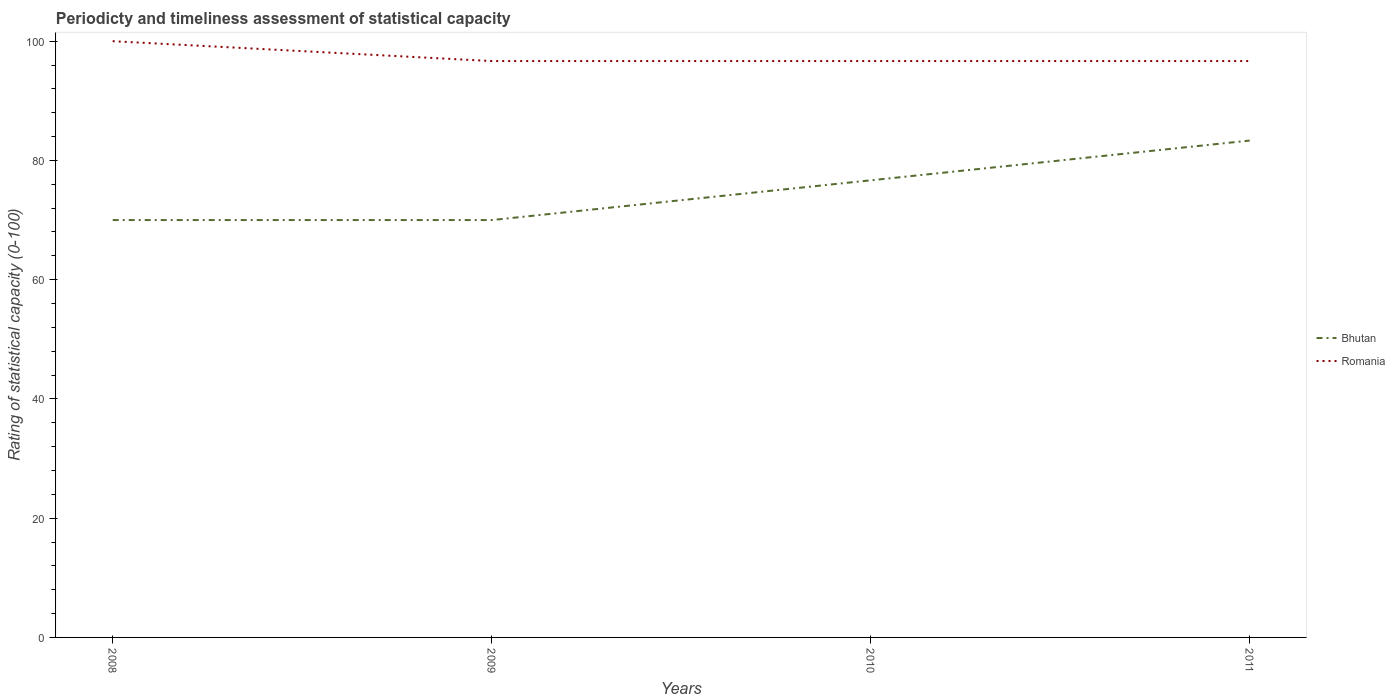Does the line corresponding to Romania intersect with the line corresponding to Bhutan?
Keep it short and to the point. No. Is the number of lines equal to the number of legend labels?
Provide a succinct answer. Yes. Across all years, what is the maximum rating of statistical capacity in Romania?
Your response must be concise. 96.67. What is the total rating of statistical capacity in Romania in the graph?
Give a very brief answer. 3.33. What is the difference between the highest and the second highest rating of statistical capacity in Bhutan?
Ensure brevity in your answer.  13.33. Is the rating of statistical capacity in Bhutan strictly greater than the rating of statistical capacity in Romania over the years?
Your response must be concise. Yes. What is the difference between two consecutive major ticks on the Y-axis?
Offer a very short reply. 20. Does the graph contain any zero values?
Your answer should be compact. No. What is the title of the graph?
Ensure brevity in your answer.  Periodicty and timeliness assessment of statistical capacity. Does "New Zealand" appear as one of the legend labels in the graph?
Ensure brevity in your answer.  No. What is the label or title of the X-axis?
Give a very brief answer. Years. What is the label or title of the Y-axis?
Make the answer very short. Rating of statistical capacity (0-100). What is the Rating of statistical capacity (0-100) of Bhutan in 2008?
Give a very brief answer. 70. What is the Rating of statistical capacity (0-100) in Romania in 2008?
Your answer should be compact. 100. What is the Rating of statistical capacity (0-100) in Romania in 2009?
Your response must be concise. 96.67. What is the Rating of statistical capacity (0-100) in Bhutan in 2010?
Your response must be concise. 76.67. What is the Rating of statistical capacity (0-100) in Romania in 2010?
Ensure brevity in your answer.  96.67. What is the Rating of statistical capacity (0-100) in Bhutan in 2011?
Ensure brevity in your answer.  83.33. What is the Rating of statistical capacity (0-100) in Romania in 2011?
Offer a very short reply. 96.67. Across all years, what is the maximum Rating of statistical capacity (0-100) of Bhutan?
Offer a terse response. 83.33. Across all years, what is the minimum Rating of statistical capacity (0-100) in Bhutan?
Provide a succinct answer. 70. Across all years, what is the minimum Rating of statistical capacity (0-100) of Romania?
Make the answer very short. 96.67. What is the total Rating of statistical capacity (0-100) of Bhutan in the graph?
Provide a short and direct response. 300. What is the total Rating of statistical capacity (0-100) in Romania in the graph?
Offer a terse response. 390. What is the difference between the Rating of statistical capacity (0-100) in Bhutan in 2008 and that in 2009?
Offer a terse response. 0. What is the difference between the Rating of statistical capacity (0-100) in Romania in 2008 and that in 2009?
Offer a terse response. 3.33. What is the difference between the Rating of statistical capacity (0-100) in Bhutan in 2008 and that in 2010?
Make the answer very short. -6.67. What is the difference between the Rating of statistical capacity (0-100) in Romania in 2008 and that in 2010?
Offer a terse response. 3.33. What is the difference between the Rating of statistical capacity (0-100) in Bhutan in 2008 and that in 2011?
Provide a succinct answer. -13.33. What is the difference between the Rating of statistical capacity (0-100) of Romania in 2008 and that in 2011?
Your answer should be very brief. 3.33. What is the difference between the Rating of statistical capacity (0-100) of Bhutan in 2009 and that in 2010?
Ensure brevity in your answer.  -6.67. What is the difference between the Rating of statistical capacity (0-100) of Romania in 2009 and that in 2010?
Your response must be concise. 0. What is the difference between the Rating of statistical capacity (0-100) in Bhutan in 2009 and that in 2011?
Your answer should be compact. -13.33. What is the difference between the Rating of statistical capacity (0-100) in Romania in 2009 and that in 2011?
Give a very brief answer. 0. What is the difference between the Rating of statistical capacity (0-100) of Bhutan in 2010 and that in 2011?
Provide a succinct answer. -6.67. What is the difference between the Rating of statistical capacity (0-100) in Bhutan in 2008 and the Rating of statistical capacity (0-100) in Romania in 2009?
Keep it short and to the point. -26.67. What is the difference between the Rating of statistical capacity (0-100) of Bhutan in 2008 and the Rating of statistical capacity (0-100) of Romania in 2010?
Your response must be concise. -26.67. What is the difference between the Rating of statistical capacity (0-100) in Bhutan in 2008 and the Rating of statistical capacity (0-100) in Romania in 2011?
Offer a terse response. -26.67. What is the difference between the Rating of statistical capacity (0-100) of Bhutan in 2009 and the Rating of statistical capacity (0-100) of Romania in 2010?
Your response must be concise. -26.67. What is the difference between the Rating of statistical capacity (0-100) of Bhutan in 2009 and the Rating of statistical capacity (0-100) of Romania in 2011?
Your response must be concise. -26.67. What is the difference between the Rating of statistical capacity (0-100) of Bhutan in 2010 and the Rating of statistical capacity (0-100) of Romania in 2011?
Make the answer very short. -20. What is the average Rating of statistical capacity (0-100) in Bhutan per year?
Provide a succinct answer. 75. What is the average Rating of statistical capacity (0-100) of Romania per year?
Provide a short and direct response. 97.5. In the year 2009, what is the difference between the Rating of statistical capacity (0-100) in Bhutan and Rating of statistical capacity (0-100) in Romania?
Ensure brevity in your answer.  -26.67. In the year 2010, what is the difference between the Rating of statistical capacity (0-100) in Bhutan and Rating of statistical capacity (0-100) in Romania?
Give a very brief answer. -20. In the year 2011, what is the difference between the Rating of statistical capacity (0-100) in Bhutan and Rating of statistical capacity (0-100) in Romania?
Make the answer very short. -13.33. What is the ratio of the Rating of statistical capacity (0-100) in Romania in 2008 to that in 2009?
Offer a very short reply. 1.03. What is the ratio of the Rating of statistical capacity (0-100) of Bhutan in 2008 to that in 2010?
Your answer should be very brief. 0.91. What is the ratio of the Rating of statistical capacity (0-100) of Romania in 2008 to that in 2010?
Offer a very short reply. 1.03. What is the ratio of the Rating of statistical capacity (0-100) of Bhutan in 2008 to that in 2011?
Provide a succinct answer. 0.84. What is the ratio of the Rating of statistical capacity (0-100) of Romania in 2008 to that in 2011?
Provide a succinct answer. 1.03. What is the ratio of the Rating of statistical capacity (0-100) of Bhutan in 2009 to that in 2011?
Keep it short and to the point. 0.84. What is the ratio of the Rating of statistical capacity (0-100) in Romania in 2009 to that in 2011?
Offer a very short reply. 1. What is the ratio of the Rating of statistical capacity (0-100) in Romania in 2010 to that in 2011?
Offer a very short reply. 1. What is the difference between the highest and the lowest Rating of statistical capacity (0-100) in Bhutan?
Give a very brief answer. 13.33. 